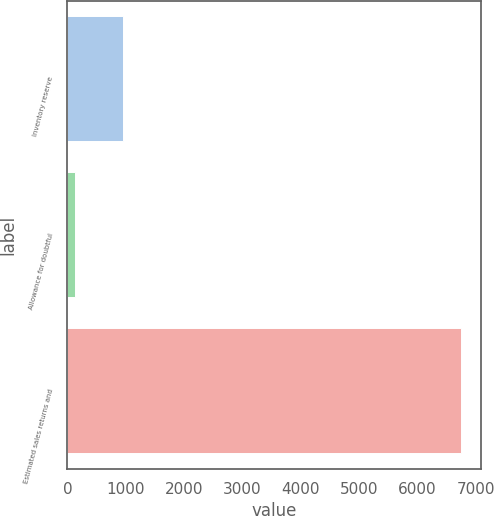<chart> <loc_0><loc_0><loc_500><loc_500><bar_chart><fcel>Inventory reserve<fcel>Allowance for doubtful<fcel>Estimated sales returns and<nl><fcel>958<fcel>136<fcel>6748<nl></chart> 